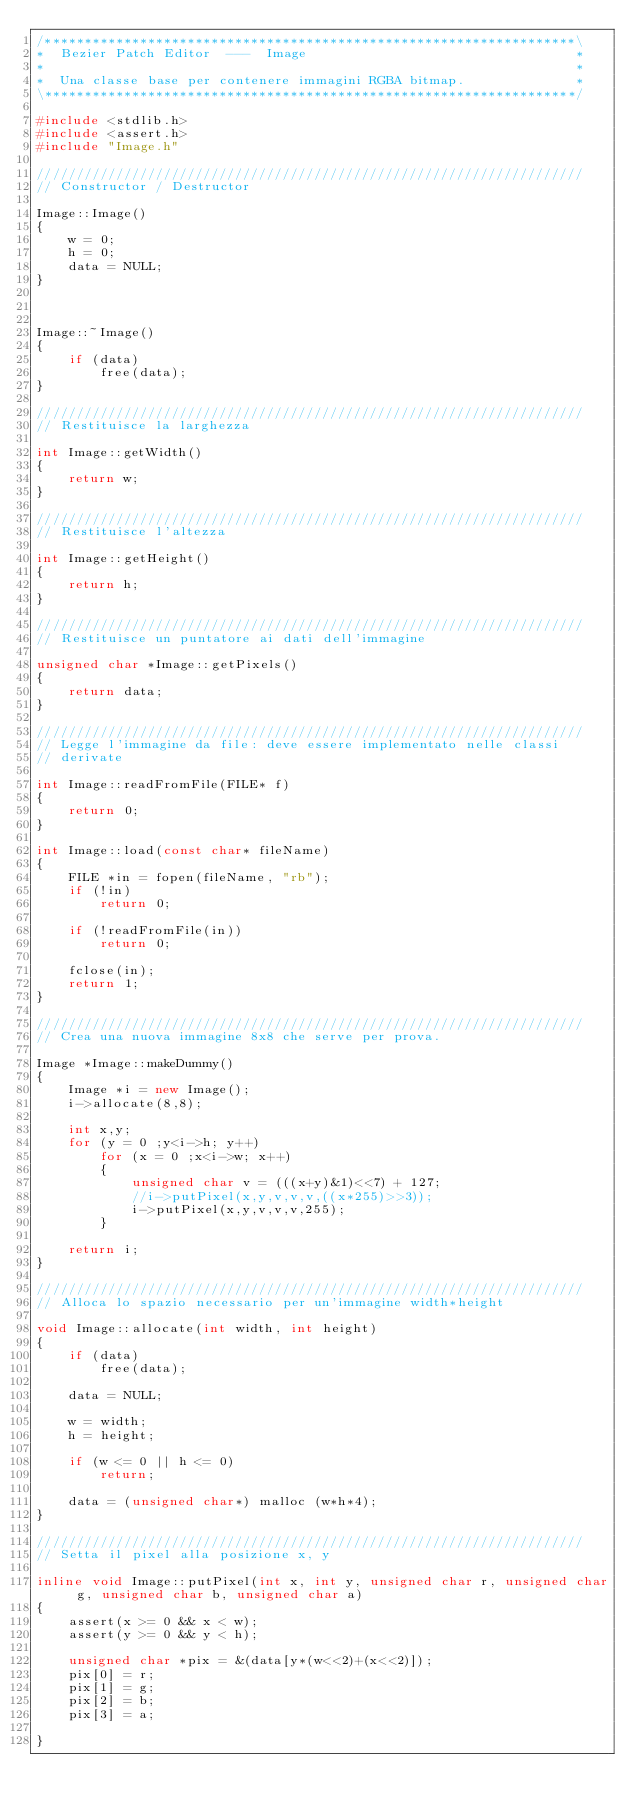<code> <loc_0><loc_0><loc_500><loc_500><_C++_>/*******************************************************************\
*  Bezier Patch Editor  ---  Image                                  *
*                                                                   *
*  Una classe base per contenere immagini RGBA bitmap.              *
\*******************************************************************/

#include <stdlib.h>
#include <assert.h>
#include "Image.h"

/////////////////////////////////////////////////////////////////////
// Constructor / Destructor

Image::Image()
{
	w = 0;
	h = 0;
	data = NULL;
}



Image::~Image()
{
	if (data)
		free(data);
}

/////////////////////////////////////////////////////////////////////
// Restituisce la larghezza

int Image::getWidth()
{
	return w;
}

/////////////////////////////////////////////////////////////////////
// Restituisce l'altezza

int Image::getHeight()
{	
	return h;
}

/////////////////////////////////////////////////////////////////////
// Restituisce un puntatore ai dati dell'immagine

unsigned char *Image::getPixels()
{
	return data;
}

/////////////////////////////////////////////////////////////////////
// Legge l'immagine da file: deve essere implementato nelle classi
// derivate

int Image::readFromFile(FILE* f)
{
	return 0;
}

int Image::load(const char* fileName)
{
	FILE *in = fopen(fileName, "rb");
	if (!in)
		return 0;

	if (!readFromFile(in))
		return 0;

	fclose(in);
	return 1;
}

/////////////////////////////////////////////////////////////////////
// Crea una nuova immagine 8x8 che serve per prova.

Image *Image::makeDummy()
{
	Image *i = new Image();
	i->allocate(8,8);

	int x,y;
	for (y = 0 ;y<i->h; y++)
		for (x = 0 ;x<i->w; x++)
		{
			unsigned char v = (((x+y)&1)<<7) + 127;
			//i->putPixel(x,y,v,v,v,((x*255)>>3));
			i->putPixel(x,y,v,v,v,255);
		}
	
	return i;
}

/////////////////////////////////////////////////////////////////////
// Alloca lo spazio necessario per un'immagine width*height 

void Image::allocate(int width, int height)
{
	if (data)
		free(data);

	data = NULL;

	w = width;
	h = height;

	if (w <= 0 || h <= 0)
		return;

	data = (unsigned char*) malloc (w*h*4);
}

/////////////////////////////////////////////////////////////////////
// Setta il pixel alla posizione x, y

inline void Image::putPixel(int x, int y, unsigned char r, unsigned char g, unsigned char b, unsigned char a)
{
	assert(x >= 0 && x < w);
	assert(y >= 0 && y < h);

	unsigned char *pix = &(data[y*(w<<2)+(x<<2)]);
	pix[0] = r;
	pix[1] = g;
	pix[2] = b;
	pix[3] = a;

}


</code> 